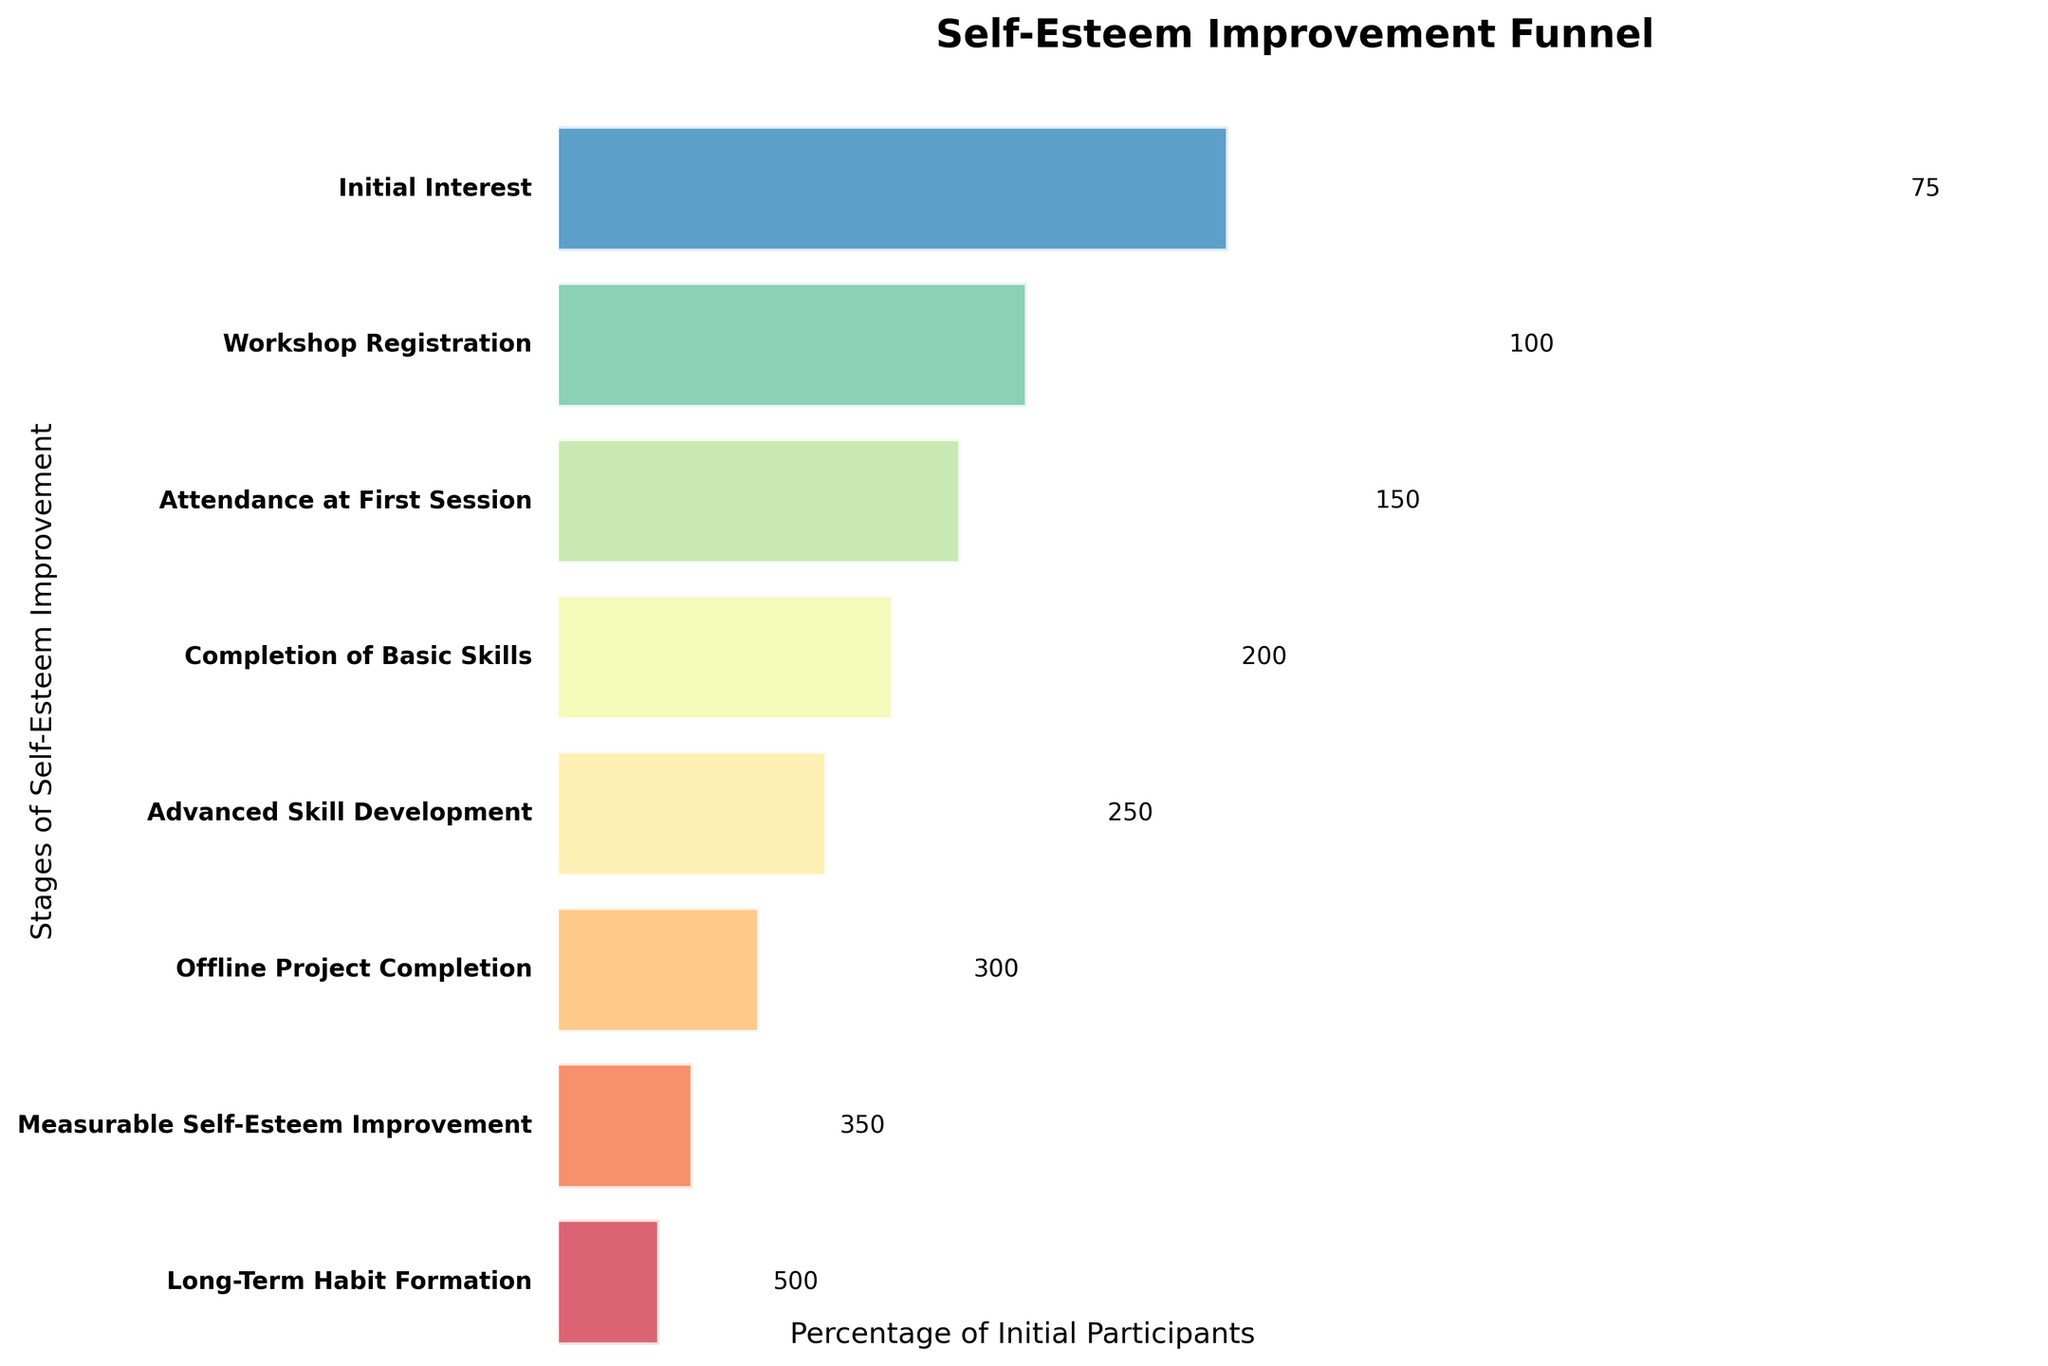what is the title of the chart? The title is displayed at the top of the chart. It provides an overview of what the chart is representing.
Answer: Self-Esteem Improvement Funnel How many stages are there in total? Count the number of different stages along the vertical axis of the funnel.
Answer: 8 In which stage do we see the first drop in participant numbers? Look at the participant counts in each stage and identify the first transition where the number decreases.
Answer: Workshop Registration How many participants attended the first session? Look for the participant count labelled next to the 'Attendance at First Session' stage.
Answer: 300 How many participants completed an offline project? Look for the participant count labelled next to the 'Offline Project Completion' stage.
Answer: 150 What is the final number of participants who achieved long-term habit formation? Look for the participant count labelled next to the 'Long-Term Habit Formation' stage at the bottom of the funnel.
Answer: 75 What percentage of initial interest participants achieved measurable self-esteem improvement? The 'Initial Interest' stage has 500 participants. The 'Measurable Self-Esteem Improvement' stage has 100 participants. The percentage is (100/500) * 100.
Answer: 20% Which stage saw the largest drop in participant numbers? To determine the largest drop, calculate the difference in participant counts between each consecutive stage and find the maximum drop. For example, Initial Interest to Workshop Registration drops by 150, Workshop Registration to Attendance at First Session drops by 50, etc.
Answer: Workshop Registration How many participants need to be added to have 200 attendees at 'Offline Project Completion'? Subtract the current number of participants at 'Offline Project Completion' (150) from the desired number (200). 200 - 150 = 50
Answer: 50 What is the difference in participant numbers between the 'Completion of Basic Skills' and 'Advanced Skill Development' stages? Subtract the number of participants in the 'Advanced Skill Development' stage (200) from the 'Completion of Basic Skills' stage (250). 250 - 200 = 50
Answer: 50 